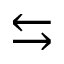Convert formula to latex. <formula><loc_0><loc_0><loc_500><loc_500>\leftrightarrow s</formula> 